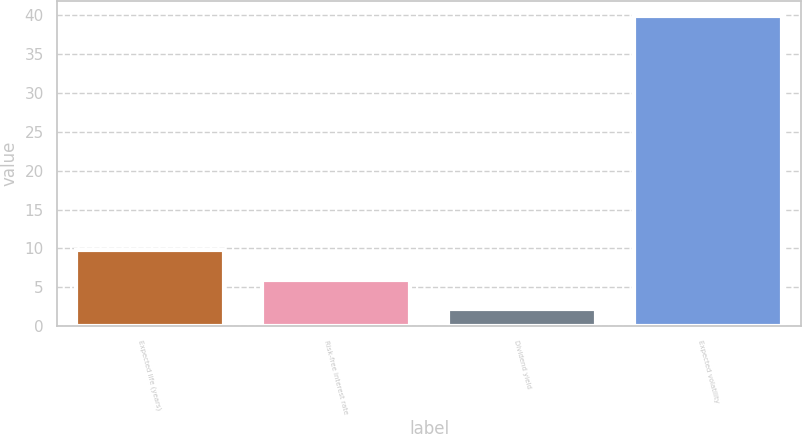<chart> <loc_0><loc_0><loc_500><loc_500><bar_chart><fcel>Expected life (years)<fcel>Risk-free interest rate<fcel>Dividend yield<fcel>Expected volatility<nl><fcel>9.74<fcel>5.97<fcel>2.2<fcel>39.9<nl></chart> 